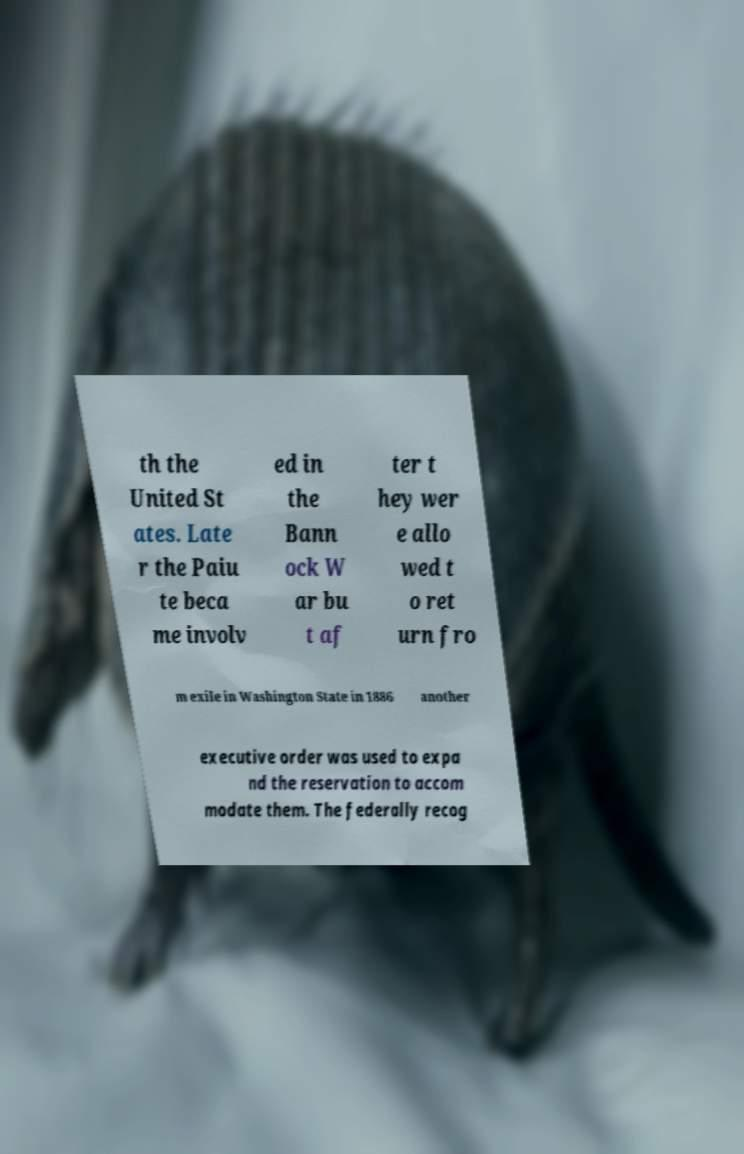Can you read and provide the text displayed in the image?This photo seems to have some interesting text. Can you extract and type it out for me? th the United St ates. Late r the Paiu te beca me involv ed in the Bann ock W ar bu t af ter t hey wer e allo wed t o ret urn fro m exile in Washington State in 1886 another executive order was used to expa nd the reservation to accom modate them. The federally recog 